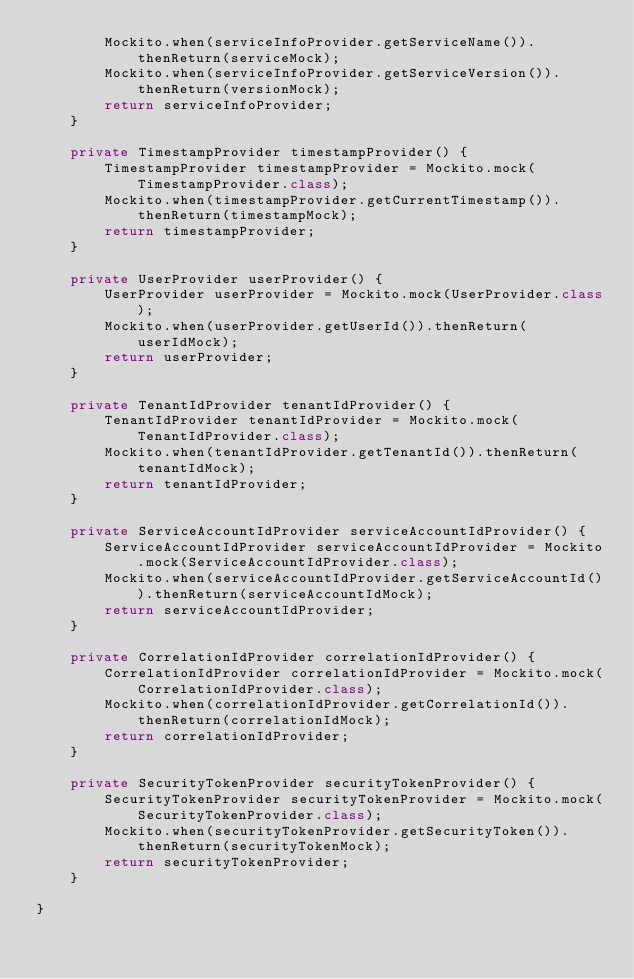Convert code to text. <code><loc_0><loc_0><loc_500><loc_500><_Java_>        Mockito.when(serviceInfoProvider.getServiceName()).thenReturn(serviceMock);
        Mockito.when(serviceInfoProvider.getServiceVersion()).thenReturn(versionMock);
        return serviceInfoProvider;
    }

    private TimestampProvider timestampProvider() {
        TimestampProvider timestampProvider = Mockito.mock(TimestampProvider.class);
        Mockito.when(timestampProvider.getCurrentTimestamp()).thenReturn(timestampMock);
        return timestampProvider;
    }

    private UserProvider userProvider() {
        UserProvider userProvider = Mockito.mock(UserProvider.class);
        Mockito.when(userProvider.getUserId()).thenReturn(userIdMock);
        return userProvider;
    }

    private TenantIdProvider tenantIdProvider() {
        TenantIdProvider tenantIdProvider = Mockito.mock(TenantIdProvider.class);
        Mockito.when(tenantIdProvider.getTenantId()).thenReturn(tenantIdMock);
        return tenantIdProvider;
    }

    private ServiceAccountIdProvider serviceAccountIdProvider() {
        ServiceAccountIdProvider serviceAccountIdProvider = Mockito.mock(ServiceAccountIdProvider.class);
        Mockito.when(serviceAccountIdProvider.getServiceAccountId()).thenReturn(serviceAccountIdMock);
        return serviceAccountIdProvider;
    }

    private CorrelationIdProvider correlationIdProvider() {
        CorrelationIdProvider correlationIdProvider = Mockito.mock(CorrelationIdProvider.class);
        Mockito.when(correlationIdProvider.getCorrelationId()).thenReturn(correlationIdMock);
        return correlationIdProvider;
    }

    private SecurityTokenProvider securityTokenProvider() {
        SecurityTokenProvider securityTokenProvider = Mockito.mock(SecurityTokenProvider.class);
        Mockito.when(securityTokenProvider.getSecurityToken()).thenReturn(securityTokenMock);
        return securityTokenProvider;
    }

}
</code> 